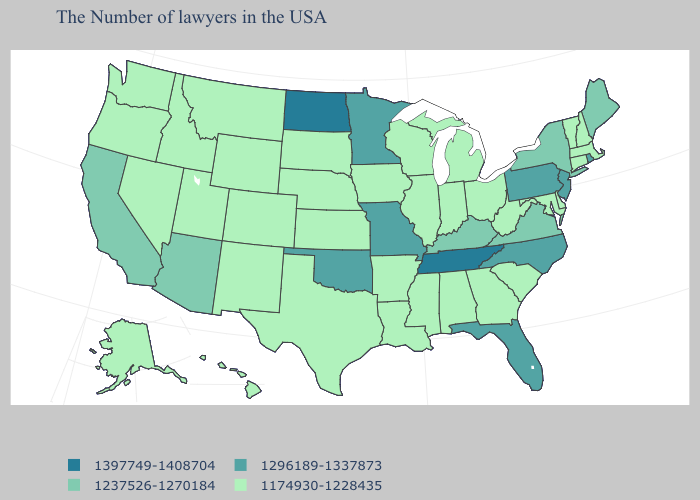Is the legend a continuous bar?
Write a very short answer. No. Does the map have missing data?
Give a very brief answer. No. Name the states that have a value in the range 1174930-1228435?
Quick response, please. Massachusetts, New Hampshire, Vermont, Connecticut, Delaware, Maryland, South Carolina, West Virginia, Ohio, Georgia, Michigan, Indiana, Alabama, Wisconsin, Illinois, Mississippi, Louisiana, Arkansas, Iowa, Kansas, Nebraska, Texas, South Dakota, Wyoming, Colorado, New Mexico, Utah, Montana, Idaho, Nevada, Washington, Oregon, Alaska, Hawaii. Does the map have missing data?
Answer briefly. No. What is the value of Hawaii?
Write a very short answer. 1174930-1228435. Among the states that border Oregon , does Idaho have the highest value?
Keep it brief. No. What is the lowest value in states that border Rhode Island?
Give a very brief answer. 1174930-1228435. Which states have the lowest value in the MidWest?
Keep it brief. Ohio, Michigan, Indiana, Wisconsin, Illinois, Iowa, Kansas, Nebraska, South Dakota. Name the states that have a value in the range 1397749-1408704?
Answer briefly. Tennessee, North Dakota. What is the highest value in the MidWest ?
Concise answer only. 1397749-1408704. What is the value of Indiana?
Answer briefly. 1174930-1228435. Does Ohio have a lower value than Rhode Island?
Answer briefly. Yes. What is the value of Oklahoma?
Give a very brief answer. 1296189-1337873. What is the highest value in the South ?
Give a very brief answer. 1397749-1408704. What is the value of Virginia?
Answer briefly. 1237526-1270184. 